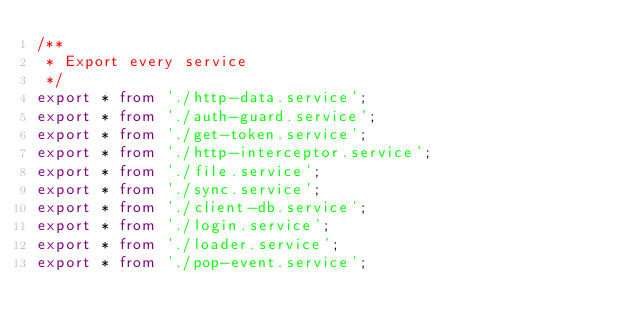Convert code to text. <code><loc_0><loc_0><loc_500><loc_500><_TypeScript_>/**
 * Export every service
 */
export * from './http-data.service';
export * from './auth-guard.service';
export * from './get-token.service';
export * from './http-interceptor.service';
export * from './file.service';
export * from './sync.service';
export * from './client-db.service';
export * from './login.service';
export * from './loader.service';
export * from './pop-event.service';
</code> 